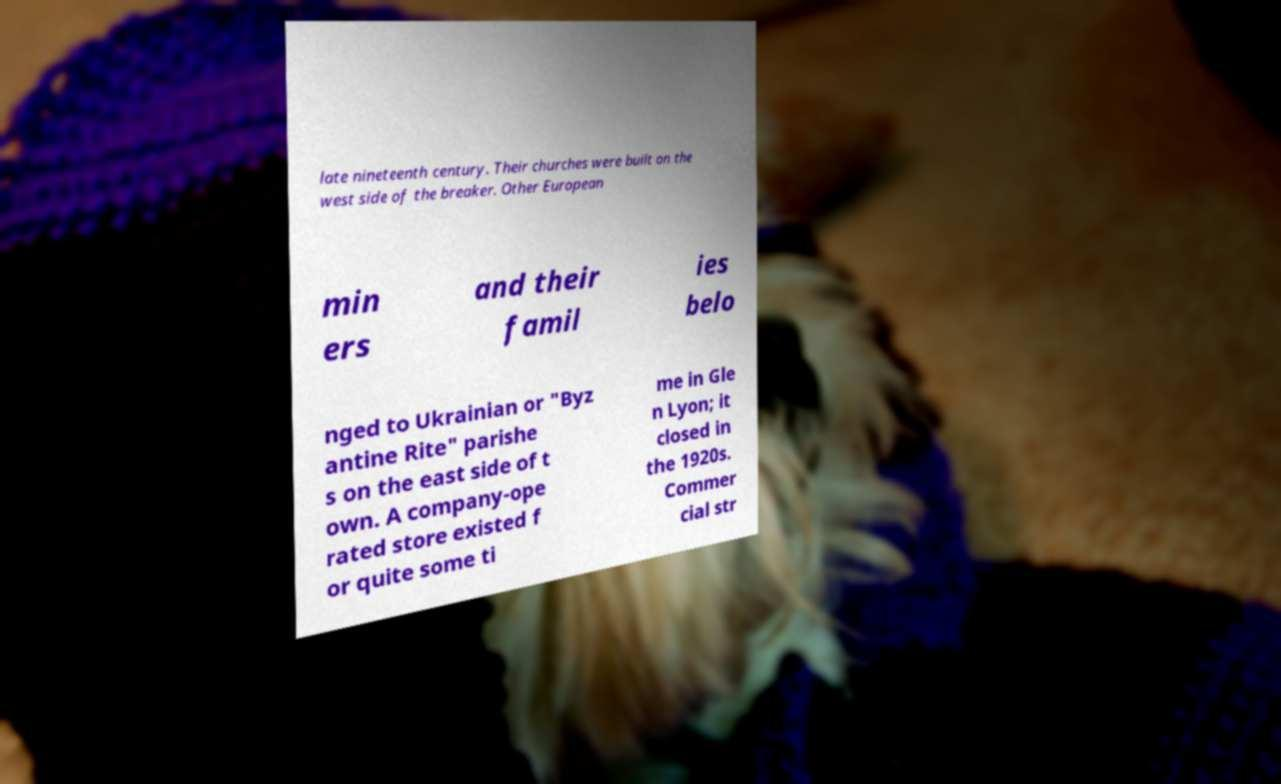Could you extract and type out the text from this image? late nineteenth century. Their churches were built on the west side of the breaker. Other European min ers and their famil ies belo nged to Ukrainian or "Byz antine Rite" parishe s on the east side of t own. A company-ope rated store existed f or quite some ti me in Gle n Lyon; it closed in the 1920s. Commer cial str 